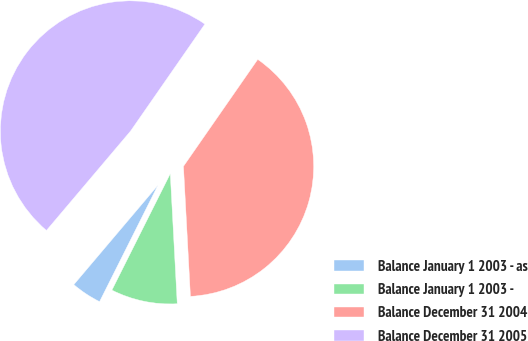Convert chart. <chart><loc_0><loc_0><loc_500><loc_500><pie_chart><fcel>Balance January 1 2003 - as<fcel>Balance January 1 2003 -<fcel>Balance December 31 2004<fcel>Balance December 31 2005<nl><fcel>3.78%<fcel>8.25%<fcel>39.48%<fcel>48.48%<nl></chart> 